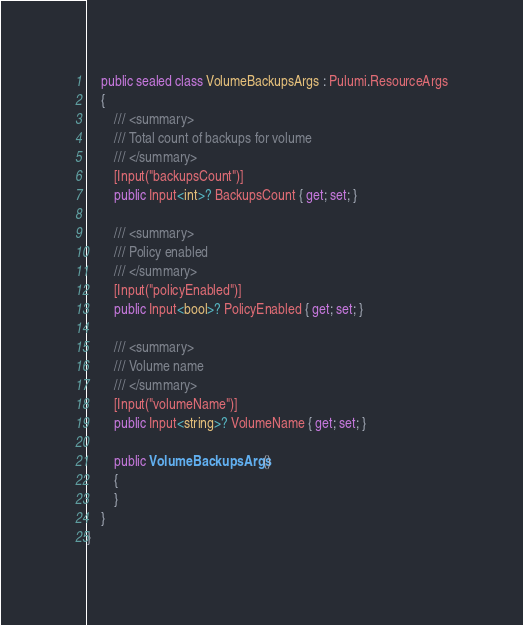Convert code to text. <code><loc_0><loc_0><loc_500><loc_500><_C#_>    public sealed class VolumeBackupsArgs : Pulumi.ResourceArgs
    {
        /// <summary>
        /// Total count of backups for volume
        /// </summary>
        [Input("backupsCount")]
        public Input<int>? BackupsCount { get; set; }

        /// <summary>
        /// Policy enabled
        /// </summary>
        [Input("policyEnabled")]
        public Input<bool>? PolicyEnabled { get; set; }

        /// <summary>
        /// Volume name
        /// </summary>
        [Input("volumeName")]
        public Input<string>? VolumeName { get; set; }

        public VolumeBackupsArgs()
        {
        }
    }
}
</code> 